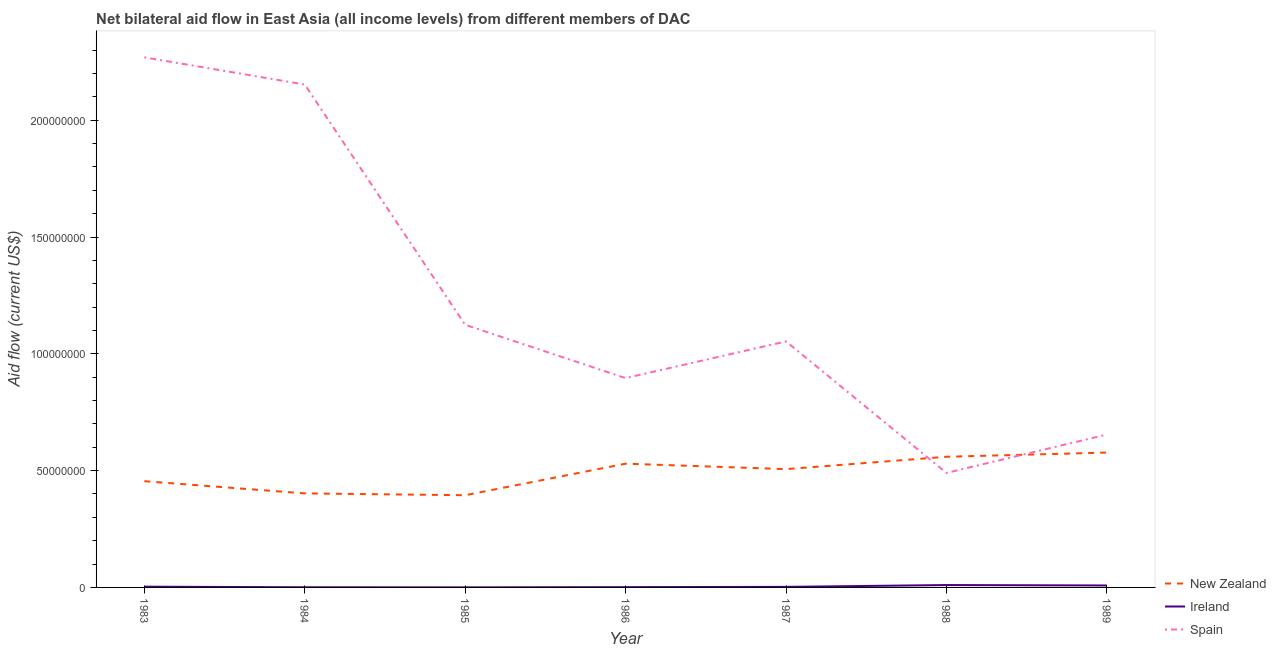How many different coloured lines are there?
Keep it short and to the point. 3. What is the amount of aid provided by new zealand in 1986?
Your response must be concise. 5.30e+07. Across all years, what is the maximum amount of aid provided by ireland?
Provide a succinct answer. 1.02e+06. Across all years, what is the minimum amount of aid provided by new zealand?
Offer a very short reply. 3.95e+07. In which year was the amount of aid provided by spain maximum?
Offer a terse response. 1983. What is the total amount of aid provided by ireland in the graph?
Make the answer very short. 2.64e+06. What is the difference between the amount of aid provided by ireland in 1984 and that in 1988?
Give a very brief answer. -9.50e+05. What is the difference between the amount of aid provided by spain in 1983 and the amount of aid provided by new zealand in 1986?
Provide a succinct answer. 1.74e+08. What is the average amount of aid provided by spain per year?
Offer a very short reply. 1.23e+08. In the year 1984, what is the difference between the amount of aid provided by ireland and amount of aid provided by spain?
Provide a short and direct response. -2.15e+08. In how many years, is the amount of aid provided by new zealand greater than 140000000 US$?
Provide a succinct answer. 0. What is the ratio of the amount of aid provided by spain in 1984 to that in 1989?
Offer a terse response. 3.29. What is the difference between the highest and the second highest amount of aid provided by new zealand?
Offer a terse response. 1.80e+06. What is the difference between the highest and the lowest amount of aid provided by new zealand?
Provide a short and direct response. 1.83e+07. Is the sum of the amount of aid provided by new zealand in 1984 and 1986 greater than the maximum amount of aid provided by spain across all years?
Your answer should be compact. No. Does the amount of aid provided by spain monotonically increase over the years?
Offer a very short reply. No. Is the amount of aid provided by spain strictly greater than the amount of aid provided by new zealand over the years?
Keep it short and to the point. No. Is the amount of aid provided by new zealand strictly less than the amount of aid provided by ireland over the years?
Your answer should be compact. No. What is the difference between two consecutive major ticks on the Y-axis?
Your answer should be very brief. 5.00e+07. Does the graph contain any zero values?
Give a very brief answer. No. Where does the legend appear in the graph?
Provide a succinct answer. Bottom right. How many legend labels are there?
Keep it short and to the point. 3. What is the title of the graph?
Provide a succinct answer. Net bilateral aid flow in East Asia (all income levels) from different members of DAC. What is the Aid flow (current US$) of New Zealand in 1983?
Give a very brief answer. 4.55e+07. What is the Aid flow (current US$) of Spain in 1983?
Make the answer very short. 2.27e+08. What is the Aid flow (current US$) of New Zealand in 1984?
Your answer should be compact. 4.02e+07. What is the Aid flow (current US$) in Ireland in 1984?
Provide a succinct answer. 7.00e+04. What is the Aid flow (current US$) in Spain in 1984?
Offer a terse response. 2.15e+08. What is the Aid flow (current US$) of New Zealand in 1985?
Give a very brief answer. 3.95e+07. What is the Aid flow (current US$) of Spain in 1985?
Provide a short and direct response. 1.12e+08. What is the Aid flow (current US$) in New Zealand in 1986?
Offer a terse response. 5.30e+07. What is the Aid flow (current US$) in Ireland in 1986?
Ensure brevity in your answer.  1.20e+05. What is the Aid flow (current US$) in Spain in 1986?
Make the answer very short. 8.96e+07. What is the Aid flow (current US$) of New Zealand in 1987?
Offer a terse response. 5.06e+07. What is the Aid flow (current US$) in Spain in 1987?
Make the answer very short. 1.05e+08. What is the Aid flow (current US$) in New Zealand in 1988?
Your response must be concise. 5.59e+07. What is the Aid flow (current US$) of Ireland in 1988?
Offer a terse response. 1.02e+06. What is the Aid flow (current US$) in Spain in 1988?
Offer a very short reply. 4.90e+07. What is the Aid flow (current US$) in New Zealand in 1989?
Provide a succinct answer. 5.77e+07. What is the Aid flow (current US$) of Ireland in 1989?
Ensure brevity in your answer.  8.40e+05. What is the Aid flow (current US$) in Spain in 1989?
Ensure brevity in your answer.  6.54e+07. Across all years, what is the maximum Aid flow (current US$) of New Zealand?
Your response must be concise. 5.77e+07. Across all years, what is the maximum Aid flow (current US$) of Ireland?
Your response must be concise. 1.02e+06. Across all years, what is the maximum Aid flow (current US$) in Spain?
Offer a terse response. 2.27e+08. Across all years, what is the minimum Aid flow (current US$) of New Zealand?
Give a very brief answer. 3.95e+07. Across all years, what is the minimum Aid flow (current US$) of Ireland?
Make the answer very short. 3.00e+04. Across all years, what is the minimum Aid flow (current US$) in Spain?
Your answer should be compact. 4.90e+07. What is the total Aid flow (current US$) in New Zealand in the graph?
Give a very brief answer. 3.42e+08. What is the total Aid flow (current US$) of Ireland in the graph?
Your response must be concise. 2.64e+06. What is the total Aid flow (current US$) in Spain in the graph?
Your answer should be compact. 8.64e+08. What is the difference between the Aid flow (current US$) of New Zealand in 1983 and that in 1984?
Ensure brevity in your answer.  5.23e+06. What is the difference between the Aid flow (current US$) in Spain in 1983 and that in 1984?
Offer a terse response. 1.16e+07. What is the difference between the Aid flow (current US$) in New Zealand in 1983 and that in 1985?
Provide a succinct answer. 6.01e+06. What is the difference between the Aid flow (current US$) of Spain in 1983 and that in 1985?
Provide a succinct answer. 1.14e+08. What is the difference between the Aid flow (current US$) in New Zealand in 1983 and that in 1986?
Offer a very short reply. -7.49e+06. What is the difference between the Aid flow (current US$) in Ireland in 1983 and that in 1986?
Ensure brevity in your answer.  2.00e+05. What is the difference between the Aid flow (current US$) in Spain in 1983 and that in 1986?
Offer a very short reply. 1.37e+08. What is the difference between the Aid flow (current US$) of New Zealand in 1983 and that in 1987?
Offer a very short reply. -5.16e+06. What is the difference between the Aid flow (current US$) in Spain in 1983 and that in 1987?
Provide a succinct answer. 1.22e+08. What is the difference between the Aid flow (current US$) in New Zealand in 1983 and that in 1988?
Make the answer very short. -1.04e+07. What is the difference between the Aid flow (current US$) in Ireland in 1983 and that in 1988?
Ensure brevity in your answer.  -7.00e+05. What is the difference between the Aid flow (current US$) in Spain in 1983 and that in 1988?
Your response must be concise. 1.78e+08. What is the difference between the Aid flow (current US$) in New Zealand in 1983 and that in 1989?
Your response must be concise. -1.22e+07. What is the difference between the Aid flow (current US$) in Ireland in 1983 and that in 1989?
Your answer should be compact. -5.20e+05. What is the difference between the Aid flow (current US$) of Spain in 1983 and that in 1989?
Keep it short and to the point. 1.61e+08. What is the difference between the Aid flow (current US$) of New Zealand in 1984 and that in 1985?
Ensure brevity in your answer.  7.80e+05. What is the difference between the Aid flow (current US$) of Ireland in 1984 and that in 1985?
Provide a succinct answer. 4.00e+04. What is the difference between the Aid flow (current US$) of Spain in 1984 and that in 1985?
Give a very brief answer. 1.03e+08. What is the difference between the Aid flow (current US$) in New Zealand in 1984 and that in 1986?
Your response must be concise. -1.27e+07. What is the difference between the Aid flow (current US$) in Ireland in 1984 and that in 1986?
Offer a terse response. -5.00e+04. What is the difference between the Aid flow (current US$) in Spain in 1984 and that in 1986?
Keep it short and to the point. 1.26e+08. What is the difference between the Aid flow (current US$) of New Zealand in 1984 and that in 1987?
Keep it short and to the point. -1.04e+07. What is the difference between the Aid flow (current US$) in Ireland in 1984 and that in 1987?
Your answer should be very brief. -1.70e+05. What is the difference between the Aid flow (current US$) in Spain in 1984 and that in 1987?
Provide a succinct answer. 1.10e+08. What is the difference between the Aid flow (current US$) in New Zealand in 1984 and that in 1988?
Ensure brevity in your answer.  -1.57e+07. What is the difference between the Aid flow (current US$) of Ireland in 1984 and that in 1988?
Provide a short and direct response. -9.50e+05. What is the difference between the Aid flow (current US$) in Spain in 1984 and that in 1988?
Your answer should be compact. 1.66e+08. What is the difference between the Aid flow (current US$) in New Zealand in 1984 and that in 1989?
Keep it short and to the point. -1.75e+07. What is the difference between the Aid flow (current US$) in Ireland in 1984 and that in 1989?
Offer a terse response. -7.70e+05. What is the difference between the Aid flow (current US$) in Spain in 1984 and that in 1989?
Ensure brevity in your answer.  1.50e+08. What is the difference between the Aid flow (current US$) of New Zealand in 1985 and that in 1986?
Provide a short and direct response. -1.35e+07. What is the difference between the Aid flow (current US$) in Ireland in 1985 and that in 1986?
Ensure brevity in your answer.  -9.00e+04. What is the difference between the Aid flow (current US$) of Spain in 1985 and that in 1986?
Keep it short and to the point. 2.28e+07. What is the difference between the Aid flow (current US$) in New Zealand in 1985 and that in 1987?
Keep it short and to the point. -1.12e+07. What is the difference between the Aid flow (current US$) of Ireland in 1985 and that in 1987?
Offer a terse response. -2.10e+05. What is the difference between the Aid flow (current US$) of Spain in 1985 and that in 1987?
Make the answer very short. 7.10e+06. What is the difference between the Aid flow (current US$) of New Zealand in 1985 and that in 1988?
Make the answer very short. -1.65e+07. What is the difference between the Aid flow (current US$) in Ireland in 1985 and that in 1988?
Keep it short and to the point. -9.90e+05. What is the difference between the Aid flow (current US$) of Spain in 1985 and that in 1988?
Offer a terse response. 6.34e+07. What is the difference between the Aid flow (current US$) in New Zealand in 1985 and that in 1989?
Provide a succinct answer. -1.83e+07. What is the difference between the Aid flow (current US$) of Ireland in 1985 and that in 1989?
Your answer should be very brief. -8.10e+05. What is the difference between the Aid flow (current US$) in Spain in 1985 and that in 1989?
Provide a succinct answer. 4.70e+07. What is the difference between the Aid flow (current US$) in New Zealand in 1986 and that in 1987?
Provide a short and direct response. 2.33e+06. What is the difference between the Aid flow (current US$) in Spain in 1986 and that in 1987?
Provide a short and direct response. -1.57e+07. What is the difference between the Aid flow (current US$) in New Zealand in 1986 and that in 1988?
Your response must be concise. -2.96e+06. What is the difference between the Aid flow (current US$) of Ireland in 1986 and that in 1988?
Provide a succinct answer. -9.00e+05. What is the difference between the Aid flow (current US$) in Spain in 1986 and that in 1988?
Make the answer very short. 4.06e+07. What is the difference between the Aid flow (current US$) in New Zealand in 1986 and that in 1989?
Provide a short and direct response. -4.76e+06. What is the difference between the Aid flow (current US$) in Ireland in 1986 and that in 1989?
Provide a succinct answer. -7.20e+05. What is the difference between the Aid flow (current US$) of Spain in 1986 and that in 1989?
Make the answer very short. 2.42e+07. What is the difference between the Aid flow (current US$) in New Zealand in 1987 and that in 1988?
Make the answer very short. -5.29e+06. What is the difference between the Aid flow (current US$) of Ireland in 1987 and that in 1988?
Make the answer very short. -7.80e+05. What is the difference between the Aid flow (current US$) of Spain in 1987 and that in 1988?
Ensure brevity in your answer.  5.63e+07. What is the difference between the Aid flow (current US$) of New Zealand in 1987 and that in 1989?
Offer a very short reply. -7.09e+06. What is the difference between the Aid flow (current US$) of Ireland in 1987 and that in 1989?
Provide a succinct answer. -6.00e+05. What is the difference between the Aid flow (current US$) in Spain in 1987 and that in 1989?
Keep it short and to the point. 3.99e+07. What is the difference between the Aid flow (current US$) of New Zealand in 1988 and that in 1989?
Make the answer very short. -1.80e+06. What is the difference between the Aid flow (current US$) of Ireland in 1988 and that in 1989?
Keep it short and to the point. 1.80e+05. What is the difference between the Aid flow (current US$) in Spain in 1988 and that in 1989?
Provide a short and direct response. -1.64e+07. What is the difference between the Aid flow (current US$) of New Zealand in 1983 and the Aid flow (current US$) of Ireland in 1984?
Your answer should be very brief. 4.54e+07. What is the difference between the Aid flow (current US$) of New Zealand in 1983 and the Aid flow (current US$) of Spain in 1984?
Your answer should be very brief. -1.70e+08. What is the difference between the Aid flow (current US$) in Ireland in 1983 and the Aid flow (current US$) in Spain in 1984?
Provide a short and direct response. -2.15e+08. What is the difference between the Aid flow (current US$) of New Zealand in 1983 and the Aid flow (current US$) of Ireland in 1985?
Provide a short and direct response. 4.54e+07. What is the difference between the Aid flow (current US$) of New Zealand in 1983 and the Aid flow (current US$) of Spain in 1985?
Your answer should be compact. -6.69e+07. What is the difference between the Aid flow (current US$) in Ireland in 1983 and the Aid flow (current US$) in Spain in 1985?
Make the answer very short. -1.12e+08. What is the difference between the Aid flow (current US$) in New Zealand in 1983 and the Aid flow (current US$) in Ireland in 1986?
Your response must be concise. 4.54e+07. What is the difference between the Aid flow (current US$) in New Zealand in 1983 and the Aid flow (current US$) in Spain in 1986?
Offer a very short reply. -4.41e+07. What is the difference between the Aid flow (current US$) in Ireland in 1983 and the Aid flow (current US$) in Spain in 1986?
Provide a short and direct response. -8.93e+07. What is the difference between the Aid flow (current US$) in New Zealand in 1983 and the Aid flow (current US$) in Ireland in 1987?
Provide a short and direct response. 4.52e+07. What is the difference between the Aid flow (current US$) in New Zealand in 1983 and the Aid flow (current US$) in Spain in 1987?
Your answer should be compact. -5.98e+07. What is the difference between the Aid flow (current US$) of Ireland in 1983 and the Aid flow (current US$) of Spain in 1987?
Provide a succinct answer. -1.05e+08. What is the difference between the Aid flow (current US$) of New Zealand in 1983 and the Aid flow (current US$) of Ireland in 1988?
Your answer should be very brief. 4.45e+07. What is the difference between the Aid flow (current US$) of New Zealand in 1983 and the Aid flow (current US$) of Spain in 1988?
Provide a succinct answer. -3.53e+06. What is the difference between the Aid flow (current US$) in Ireland in 1983 and the Aid flow (current US$) in Spain in 1988?
Provide a short and direct response. -4.87e+07. What is the difference between the Aid flow (current US$) of New Zealand in 1983 and the Aid flow (current US$) of Ireland in 1989?
Keep it short and to the point. 4.46e+07. What is the difference between the Aid flow (current US$) of New Zealand in 1983 and the Aid flow (current US$) of Spain in 1989?
Ensure brevity in your answer.  -2.00e+07. What is the difference between the Aid flow (current US$) of Ireland in 1983 and the Aid flow (current US$) of Spain in 1989?
Provide a short and direct response. -6.51e+07. What is the difference between the Aid flow (current US$) in New Zealand in 1984 and the Aid flow (current US$) in Ireland in 1985?
Make the answer very short. 4.02e+07. What is the difference between the Aid flow (current US$) in New Zealand in 1984 and the Aid flow (current US$) in Spain in 1985?
Your response must be concise. -7.22e+07. What is the difference between the Aid flow (current US$) of Ireland in 1984 and the Aid flow (current US$) of Spain in 1985?
Your answer should be very brief. -1.12e+08. What is the difference between the Aid flow (current US$) of New Zealand in 1984 and the Aid flow (current US$) of Ireland in 1986?
Offer a very short reply. 4.01e+07. What is the difference between the Aid flow (current US$) of New Zealand in 1984 and the Aid flow (current US$) of Spain in 1986?
Your answer should be compact. -4.94e+07. What is the difference between the Aid flow (current US$) of Ireland in 1984 and the Aid flow (current US$) of Spain in 1986?
Your answer should be compact. -8.95e+07. What is the difference between the Aid flow (current US$) of New Zealand in 1984 and the Aid flow (current US$) of Ireland in 1987?
Your answer should be compact. 4.00e+07. What is the difference between the Aid flow (current US$) in New Zealand in 1984 and the Aid flow (current US$) in Spain in 1987?
Ensure brevity in your answer.  -6.51e+07. What is the difference between the Aid flow (current US$) in Ireland in 1984 and the Aid flow (current US$) in Spain in 1987?
Offer a terse response. -1.05e+08. What is the difference between the Aid flow (current US$) of New Zealand in 1984 and the Aid flow (current US$) of Ireland in 1988?
Offer a very short reply. 3.92e+07. What is the difference between the Aid flow (current US$) in New Zealand in 1984 and the Aid flow (current US$) in Spain in 1988?
Provide a short and direct response. -8.76e+06. What is the difference between the Aid flow (current US$) in Ireland in 1984 and the Aid flow (current US$) in Spain in 1988?
Provide a succinct answer. -4.89e+07. What is the difference between the Aid flow (current US$) of New Zealand in 1984 and the Aid flow (current US$) of Ireland in 1989?
Ensure brevity in your answer.  3.94e+07. What is the difference between the Aid flow (current US$) of New Zealand in 1984 and the Aid flow (current US$) of Spain in 1989?
Ensure brevity in your answer.  -2.52e+07. What is the difference between the Aid flow (current US$) in Ireland in 1984 and the Aid flow (current US$) in Spain in 1989?
Make the answer very short. -6.54e+07. What is the difference between the Aid flow (current US$) in New Zealand in 1985 and the Aid flow (current US$) in Ireland in 1986?
Ensure brevity in your answer.  3.94e+07. What is the difference between the Aid flow (current US$) in New Zealand in 1985 and the Aid flow (current US$) in Spain in 1986?
Your answer should be very brief. -5.01e+07. What is the difference between the Aid flow (current US$) of Ireland in 1985 and the Aid flow (current US$) of Spain in 1986?
Keep it short and to the point. -8.96e+07. What is the difference between the Aid flow (current US$) in New Zealand in 1985 and the Aid flow (current US$) in Ireland in 1987?
Provide a succinct answer. 3.92e+07. What is the difference between the Aid flow (current US$) in New Zealand in 1985 and the Aid flow (current US$) in Spain in 1987?
Make the answer very short. -6.58e+07. What is the difference between the Aid flow (current US$) of Ireland in 1985 and the Aid flow (current US$) of Spain in 1987?
Keep it short and to the point. -1.05e+08. What is the difference between the Aid flow (current US$) of New Zealand in 1985 and the Aid flow (current US$) of Ireland in 1988?
Ensure brevity in your answer.  3.84e+07. What is the difference between the Aid flow (current US$) of New Zealand in 1985 and the Aid flow (current US$) of Spain in 1988?
Your answer should be very brief. -9.54e+06. What is the difference between the Aid flow (current US$) of Ireland in 1985 and the Aid flow (current US$) of Spain in 1988?
Provide a succinct answer. -4.90e+07. What is the difference between the Aid flow (current US$) in New Zealand in 1985 and the Aid flow (current US$) in Ireland in 1989?
Your answer should be very brief. 3.86e+07. What is the difference between the Aid flow (current US$) in New Zealand in 1985 and the Aid flow (current US$) in Spain in 1989?
Provide a succinct answer. -2.60e+07. What is the difference between the Aid flow (current US$) of Ireland in 1985 and the Aid flow (current US$) of Spain in 1989?
Ensure brevity in your answer.  -6.54e+07. What is the difference between the Aid flow (current US$) of New Zealand in 1986 and the Aid flow (current US$) of Ireland in 1987?
Your answer should be compact. 5.27e+07. What is the difference between the Aid flow (current US$) in New Zealand in 1986 and the Aid flow (current US$) in Spain in 1987?
Provide a short and direct response. -5.23e+07. What is the difference between the Aid flow (current US$) in Ireland in 1986 and the Aid flow (current US$) in Spain in 1987?
Give a very brief answer. -1.05e+08. What is the difference between the Aid flow (current US$) in New Zealand in 1986 and the Aid flow (current US$) in Ireland in 1988?
Offer a very short reply. 5.20e+07. What is the difference between the Aid flow (current US$) of New Zealand in 1986 and the Aid flow (current US$) of Spain in 1988?
Make the answer very short. 3.96e+06. What is the difference between the Aid flow (current US$) in Ireland in 1986 and the Aid flow (current US$) in Spain in 1988?
Make the answer very short. -4.89e+07. What is the difference between the Aid flow (current US$) of New Zealand in 1986 and the Aid flow (current US$) of Ireland in 1989?
Your answer should be compact. 5.21e+07. What is the difference between the Aid flow (current US$) in New Zealand in 1986 and the Aid flow (current US$) in Spain in 1989?
Offer a terse response. -1.25e+07. What is the difference between the Aid flow (current US$) in Ireland in 1986 and the Aid flow (current US$) in Spain in 1989?
Ensure brevity in your answer.  -6.53e+07. What is the difference between the Aid flow (current US$) in New Zealand in 1987 and the Aid flow (current US$) in Ireland in 1988?
Your answer should be very brief. 4.96e+07. What is the difference between the Aid flow (current US$) in New Zealand in 1987 and the Aid flow (current US$) in Spain in 1988?
Provide a short and direct response. 1.63e+06. What is the difference between the Aid flow (current US$) in Ireland in 1987 and the Aid flow (current US$) in Spain in 1988?
Offer a terse response. -4.88e+07. What is the difference between the Aid flow (current US$) of New Zealand in 1987 and the Aid flow (current US$) of Ireland in 1989?
Offer a terse response. 4.98e+07. What is the difference between the Aid flow (current US$) in New Zealand in 1987 and the Aid flow (current US$) in Spain in 1989?
Ensure brevity in your answer.  -1.48e+07. What is the difference between the Aid flow (current US$) in Ireland in 1987 and the Aid flow (current US$) in Spain in 1989?
Your answer should be compact. -6.52e+07. What is the difference between the Aid flow (current US$) of New Zealand in 1988 and the Aid flow (current US$) of Ireland in 1989?
Provide a short and direct response. 5.51e+07. What is the difference between the Aid flow (current US$) in New Zealand in 1988 and the Aid flow (current US$) in Spain in 1989?
Your answer should be very brief. -9.52e+06. What is the difference between the Aid flow (current US$) in Ireland in 1988 and the Aid flow (current US$) in Spain in 1989?
Your answer should be compact. -6.44e+07. What is the average Aid flow (current US$) of New Zealand per year?
Offer a terse response. 4.89e+07. What is the average Aid flow (current US$) in Ireland per year?
Your response must be concise. 3.77e+05. What is the average Aid flow (current US$) of Spain per year?
Provide a short and direct response. 1.23e+08. In the year 1983, what is the difference between the Aid flow (current US$) in New Zealand and Aid flow (current US$) in Ireland?
Offer a terse response. 4.52e+07. In the year 1983, what is the difference between the Aid flow (current US$) of New Zealand and Aid flow (current US$) of Spain?
Make the answer very short. -1.81e+08. In the year 1983, what is the difference between the Aid flow (current US$) in Ireland and Aid flow (current US$) in Spain?
Your answer should be compact. -2.27e+08. In the year 1984, what is the difference between the Aid flow (current US$) in New Zealand and Aid flow (current US$) in Ireland?
Your answer should be compact. 4.02e+07. In the year 1984, what is the difference between the Aid flow (current US$) in New Zealand and Aid flow (current US$) in Spain?
Provide a short and direct response. -1.75e+08. In the year 1984, what is the difference between the Aid flow (current US$) in Ireland and Aid flow (current US$) in Spain?
Offer a very short reply. -2.15e+08. In the year 1985, what is the difference between the Aid flow (current US$) of New Zealand and Aid flow (current US$) of Ireland?
Your response must be concise. 3.94e+07. In the year 1985, what is the difference between the Aid flow (current US$) of New Zealand and Aid flow (current US$) of Spain?
Your answer should be compact. -7.29e+07. In the year 1985, what is the difference between the Aid flow (current US$) in Ireland and Aid flow (current US$) in Spain?
Your answer should be very brief. -1.12e+08. In the year 1986, what is the difference between the Aid flow (current US$) in New Zealand and Aid flow (current US$) in Ireland?
Provide a short and direct response. 5.28e+07. In the year 1986, what is the difference between the Aid flow (current US$) of New Zealand and Aid flow (current US$) of Spain?
Ensure brevity in your answer.  -3.66e+07. In the year 1986, what is the difference between the Aid flow (current US$) in Ireland and Aid flow (current US$) in Spain?
Ensure brevity in your answer.  -8.95e+07. In the year 1987, what is the difference between the Aid flow (current US$) in New Zealand and Aid flow (current US$) in Ireland?
Keep it short and to the point. 5.04e+07. In the year 1987, what is the difference between the Aid flow (current US$) in New Zealand and Aid flow (current US$) in Spain?
Your response must be concise. -5.47e+07. In the year 1987, what is the difference between the Aid flow (current US$) of Ireland and Aid flow (current US$) of Spain?
Ensure brevity in your answer.  -1.05e+08. In the year 1988, what is the difference between the Aid flow (current US$) in New Zealand and Aid flow (current US$) in Ireland?
Your answer should be very brief. 5.49e+07. In the year 1988, what is the difference between the Aid flow (current US$) of New Zealand and Aid flow (current US$) of Spain?
Provide a succinct answer. 6.92e+06. In the year 1988, what is the difference between the Aid flow (current US$) of Ireland and Aid flow (current US$) of Spain?
Make the answer very short. -4.80e+07. In the year 1989, what is the difference between the Aid flow (current US$) in New Zealand and Aid flow (current US$) in Ireland?
Offer a very short reply. 5.69e+07. In the year 1989, what is the difference between the Aid flow (current US$) of New Zealand and Aid flow (current US$) of Spain?
Your response must be concise. -7.72e+06. In the year 1989, what is the difference between the Aid flow (current US$) in Ireland and Aid flow (current US$) in Spain?
Make the answer very short. -6.46e+07. What is the ratio of the Aid flow (current US$) in New Zealand in 1983 to that in 1984?
Make the answer very short. 1.13. What is the ratio of the Aid flow (current US$) in Ireland in 1983 to that in 1984?
Give a very brief answer. 4.57. What is the ratio of the Aid flow (current US$) in Spain in 1983 to that in 1984?
Your answer should be compact. 1.05. What is the ratio of the Aid flow (current US$) of New Zealand in 1983 to that in 1985?
Provide a succinct answer. 1.15. What is the ratio of the Aid flow (current US$) in Ireland in 1983 to that in 1985?
Give a very brief answer. 10.67. What is the ratio of the Aid flow (current US$) of Spain in 1983 to that in 1985?
Offer a very short reply. 2.02. What is the ratio of the Aid flow (current US$) in New Zealand in 1983 to that in 1986?
Ensure brevity in your answer.  0.86. What is the ratio of the Aid flow (current US$) in Ireland in 1983 to that in 1986?
Your response must be concise. 2.67. What is the ratio of the Aid flow (current US$) in Spain in 1983 to that in 1986?
Your response must be concise. 2.53. What is the ratio of the Aid flow (current US$) in New Zealand in 1983 to that in 1987?
Make the answer very short. 0.9. What is the ratio of the Aid flow (current US$) in Ireland in 1983 to that in 1987?
Offer a very short reply. 1.33. What is the ratio of the Aid flow (current US$) in Spain in 1983 to that in 1987?
Ensure brevity in your answer.  2.15. What is the ratio of the Aid flow (current US$) in New Zealand in 1983 to that in 1988?
Provide a succinct answer. 0.81. What is the ratio of the Aid flow (current US$) in Ireland in 1983 to that in 1988?
Offer a very short reply. 0.31. What is the ratio of the Aid flow (current US$) in Spain in 1983 to that in 1988?
Keep it short and to the point. 4.63. What is the ratio of the Aid flow (current US$) of New Zealand in 1983 to that in 1989?
Give a very brief answer. 0.79. What is the ratio of the Aid flow (current US$) of Ireland in 1983 to that in 1989?
Provide a succinct answer. 0.38. What is the ratio of the Aid flow (current US$) of Spain in 1983 to that in 1989?
Your response must be concise. 3.47. What is the ratio of the Aid flow (current US$) of New Zealand in 1984 to that in 1985?
Ensure brevity in your answer.  1.02. What is the ratio of the Aid flow (current US$) in Ireland in 1984 to that in 1985?
Your answer should be compact. 2.33. What is the ratio of the Aid flow (current US$) of Spain in 1984 to that in 1985?
Offer a terse response. 1.92. What is the ratio of the Aid flow (current US$) of New Zealand in 1984 to that in 1986?
Offer a very short reply. 0.76. What is the ratio of the Aid flow (current US$) in Ireland in 1984 to that in 1986?
Your answer should be compact. 0.58. What is the ratio of the Aid flow (current US$) in Spain in 1984 to that in 1986?
Ensure brevity in your answer.  2.4. What is the ratio of the Aid flow (current US$) in New Zealand in 1984 to that in 1987?
Your answer should be very brief. 0.79. What is the ratio of the Aid flow (current US$) in Ireland in 1984 to that in 1987?
Your response must be concise. 0.29. What is the ratio of the Aid flow (current US$) in Spain in 1984 to that in 1987?
Your answer should be compact. 2.04. What is the ratio of the Aid flow (current US$) of New Zealand in 1984 to that in 1988?
Ensure brevity in your answer.  0.72. What is the ratio of the Aid flow (current US$) of Ireland in 1984 to that in 1988?
Provide a short and direct response. 0.07. What is the ratio of the Aid flow (current US$) of Spain in 1984 to that in 1988?
Provide a short and direct response. 4.39. What is the ratio of the Aid flow (current US$) of New Zealand in 1984 to that in 1989?
Give a very brief answer. 0.7. What is the ratio of the Aid flow (current US$) in Ireland in 1984 to that in 1989?
Your response must be concise. 0.08. What is the ratio of the Aid flow (current US$) in Spain in 1984 to that in 1989?
Provide a succinct answer. 3.29. What is the ratio of the Aid flow (current US$) of New Zealand in 1985 to that in 1986?
Give a very brief answer. 0.75. What is the ratio of the Aid flow (current US$) in Spain in 1985 to that in 1986?
Ensure brevity in your answer.  1.25. What is the ratio of the Aid flow (current US$) of New Zealand in 1985 to that in 1987?
Offer a very short reply. 0.78. What is the ratio of the Aid flow (current US$) of Ireland in 1985 to that in 1987?
Ensure brevity in your answer.  0.12. What is the ratio of the Aid flow (current US$) in Spain in 1985 to that in 1987?
Your answer should be compact. 1.07. What is the ratio of the Aid flow (current US$) in New Zealand in 1985 to that in 1988?
Your answer should be very brief. 0.71. What is the ratio of the Aid flow (current US$) of Ireland in 1985 to that in 1988?
Ensure brevity in your answer.  0.03. What is the ratio of the Aid flow (current US$) of Spain in 1985 to that in 1988?
Provide a short and direct response. 2.29. What is the ratio of the Aid flow (current US$) in New Zealand in 1985 to that in 1989?
Ensure brevity in your answer.  0.68. What is the ratio of the Aid flow (current US$) in Ireland in 1985 to that in 1989?
Your answer should be compact. 0.04. What is the ratio of the Aid flow (current US$) in Spain in 1985 to that in 1989?
Your response must be concise. 1.72. What is the ratio of the Aid flow (current US$) in New Zealand in 1986 to that in 1987?
Keep it short and to the point. 1.05. What is the ratio of the Aid flow (current US$) of Spain in 1986 to that in 1987?
Offer a very short reply. 0.85. What is the ratio of the Aid flow (current US$) in New Zealand in 1986 to that in 1988?
Keep it short and to the point. 0.95. What is the ratio of the Aid flow (current US$) in Ireland in 1986 to that in 1988?
Make the answer very short. 0.12. What is the ratio of the Aid flow (current US$) of Spain in 1986 to that in 1988?
Make the answer very short. 1.83. What is the ratio of the Aid flow (current US$) of New Zealand in 1986 to that in 1989?
Offer a very short reply. 0.92. What is the ratio of the Aid flow (current US$) of Ireland in 1986 to that in 1989?
Make the answer very short. 0.14. What is the ratio of the Aid flow (current US$) of Spain in 1986 to that in 1989?
Offer a terse response. 1.37. What is the ratio of the Aid flow (current US$) in New Zealand in 1987 to that in 1988?
Make the answer very short. 0.91. What is the ratio of the Aid flow (current US$) of Ireland in 1987 to that in 1988?
Give a very brief answer. 0.24. What is the ratio of the Aid flow (current US$) in Spain in 1987 to that in 1988?
Offer a terse response. 2.15. What is the ratio of the Aid flow (current US$) in New Zealand in 1987 to that in 1989?
Make the answer very short. 0.88. What is the ratio of the Aid flow (current US$) in Ireland in 1987 to that in 1989?
Your answer should be compact. 0.29. What is the ratio of the Aid flow (current US$) in Spain in 1987 to that in 1989?
Your answer should be compact. 1.61. What is the ratio of the Aid flow (current US$) of New Zealand in 1988 to that in 1989?
Your response must be concise. 0.97. What is the ratio of the Aid flow (current US$) in Ireland in 1988 to that in 1989?
Ensure brevity in your answer.  1.21. What is the ratio of the Aid flow (current US$) in Spain in 1988 to that in 1989?
Offer a very short reply. 0.75. What is the difference between the highest and the second highest Aid flow (current US$) in New Zealand?
Provide a short and direct response. 1.80e+06. What is the difference between the highest and the second highest Aid flow (current US$) in Ireland?
Your answer should be very brief. 1.80e+05. What is the difference between the highest and the second highest Aid flow (current US$) of Spain?
Give a very brief answer. 1.16e+07. What is the difference between the highest and the lowest Aid flow (current US$) in New Zealand?
Your answer should be very brief. 1.83e+07. What is the difference between the highest and the lowest Aid flow (current US$) in Ireland?
Provide a succinct answer. 9.90e+05. What is the difference between the highest and the lowest Aid flow (current US$) in Spain?
Make the answer very short. 1.78e+08. 